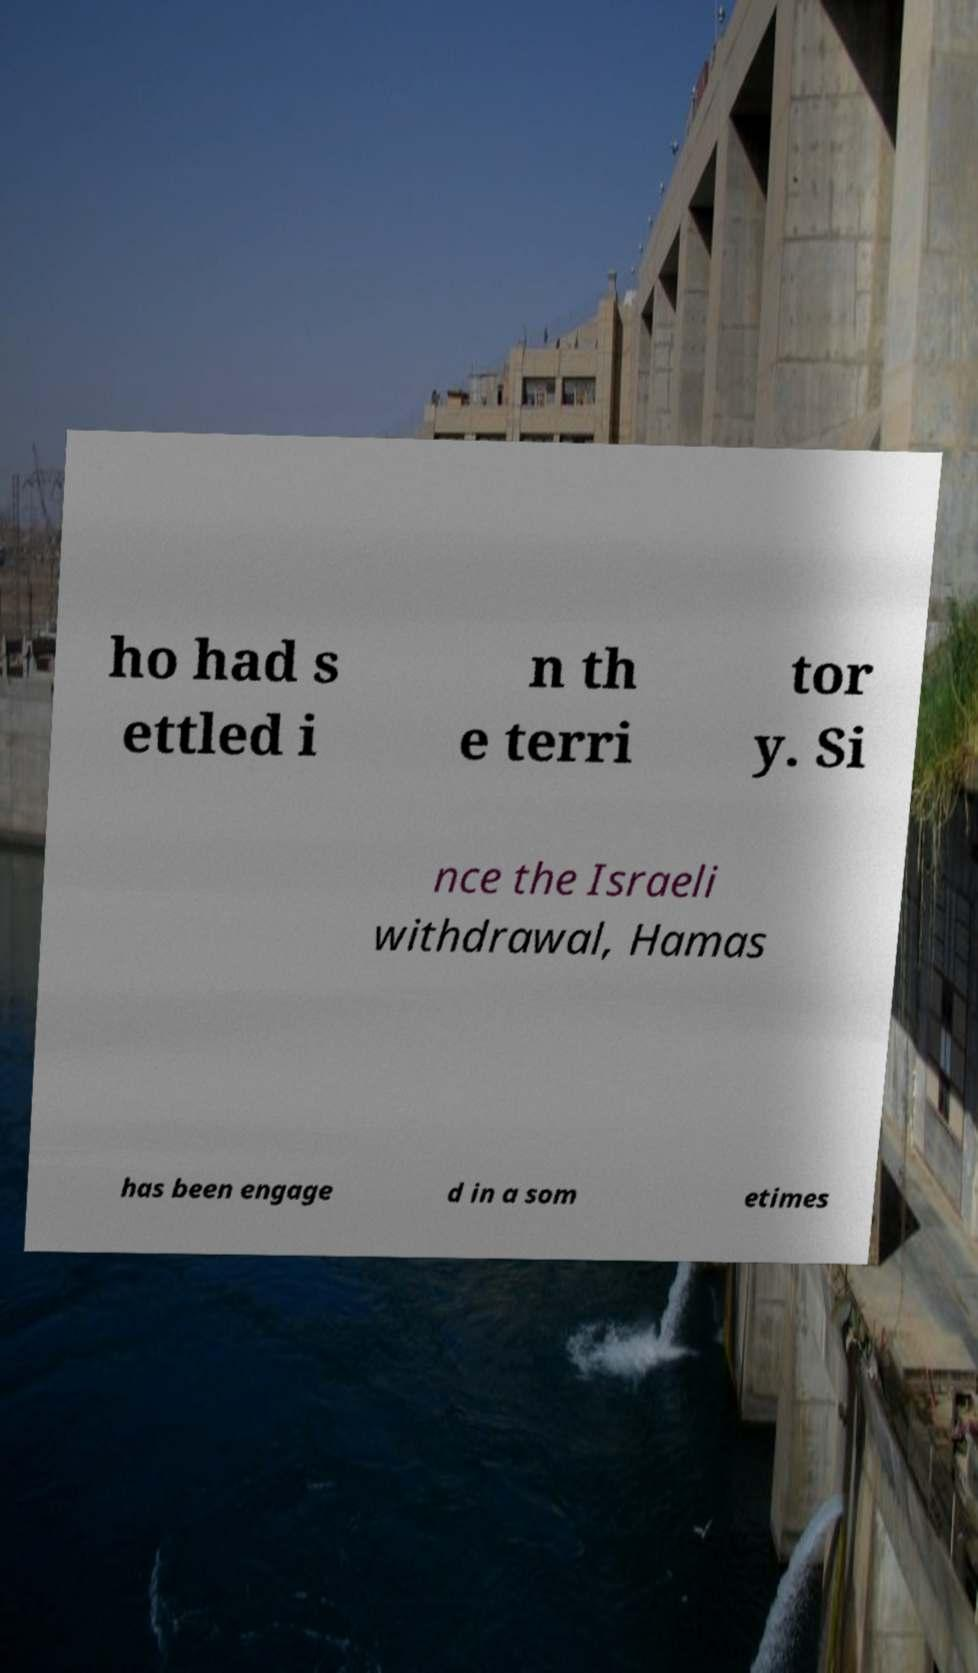Could you assist in decoding the text presented in this image and type it out clearly? ho had s ettled i n th e terri tor y. Si nce the Israeli withdrawal, Hamas has been engage d in a som etimes 